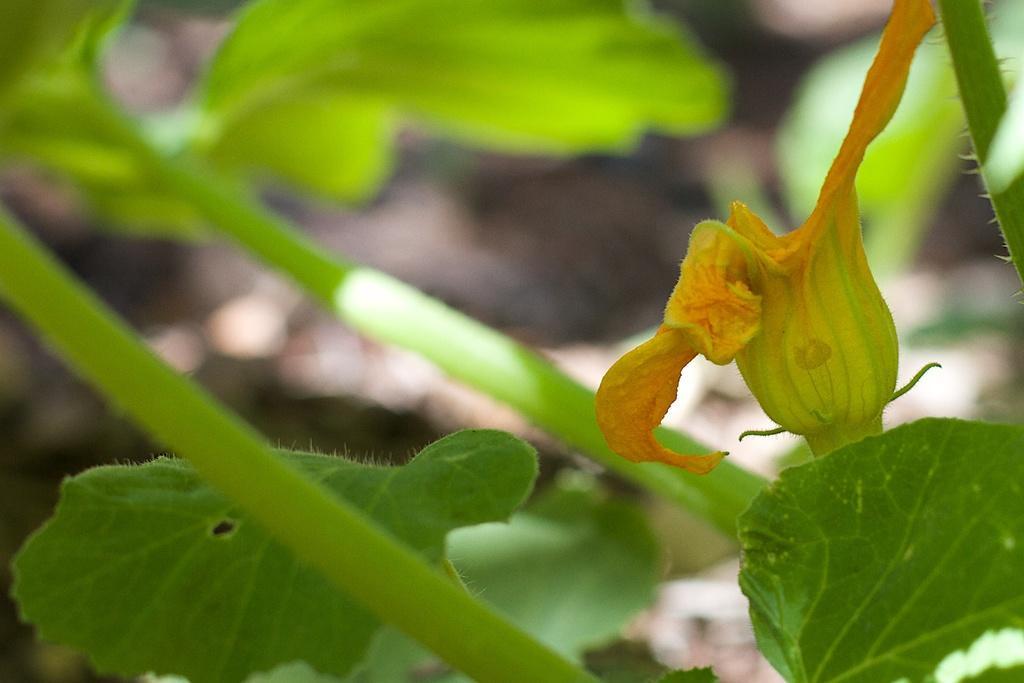Please provide a concise description of this image. In this picture we can see green leaves and a yellow flower. 